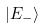Convert formula to latex. <formula><loc_0><loc_0><loc_500><loc_500>| E _ { - } \rangle</formula> 